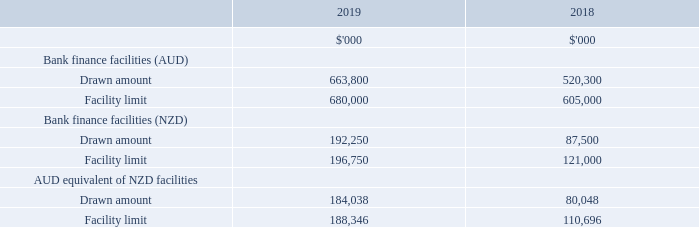The Group has non-current borrowing facilities denominated in Australian Dollars (“AUD”) and New Zealand Dollars (“NZD”). All facilities are interest only facilities with any drawn balances payable at maturity. Drawn amounts and facility limits are as follows:
The major terms of these agreements are as follows: • Maturity dates on the facilities range from 23 July 2020 to 23 December 2026 (2018: 23 July 2019 to 23 December 2026). • The interest rate applied is the bank bill rate plus a margin depending on the gearing ratio. • Security has been granted over the Group's freehold investment properties.
The Group has a bank overdraft facility with a limit of $3m that was undrawn at 30 June 2019 and 30 June 2018. During the year ended 30 June 2019, the Group converted an existing AUD facility of $25m into an NZD facility of $25.75m, refinanced part of the existing debt facilities, and increased its club banking facilities by AUD $100m and NZD $50m (year ended 30 June 2018 facilities increased by $150m AUD and $25m NZD).
The Group have complied with the financial covenants of their borrowing facilities during the 2019 and 2018 reporting periods (see note 16). The fair value of borrowings approximates carrying value. Details of the exposure to risk arising from current and non-current borrowings are set out in note 15.
What is the range of maturity dates on the facilities in 2018? 23 july 2019 to 23 december 2026. What is the drawn amount from bank finance facilities (AUD) in 2019?
Answer scale should be: thousand. 663,800. What is the drawn amount from bank finance facilities (AUD) in 2018?
Answer scale should be: thousand. 520,300. What is the change in Bank finance facilities (AUD) Drawn amount from 2018 to 2019?
Answer scale should be: thousand. 663,800-520,300
Answer: 143500. What is the change in Bank finance facilities (AUD) Facility limit from 2018 to 2019?
Answer scale should be: thousand. 680,000-605,000
Answer: 75000. What is the change in Bank finance facilities (NZD) Drawn amount from 2018 to 2019?
Answer scale should be: thousand. 192,250-87,500
Answer: 104750. 